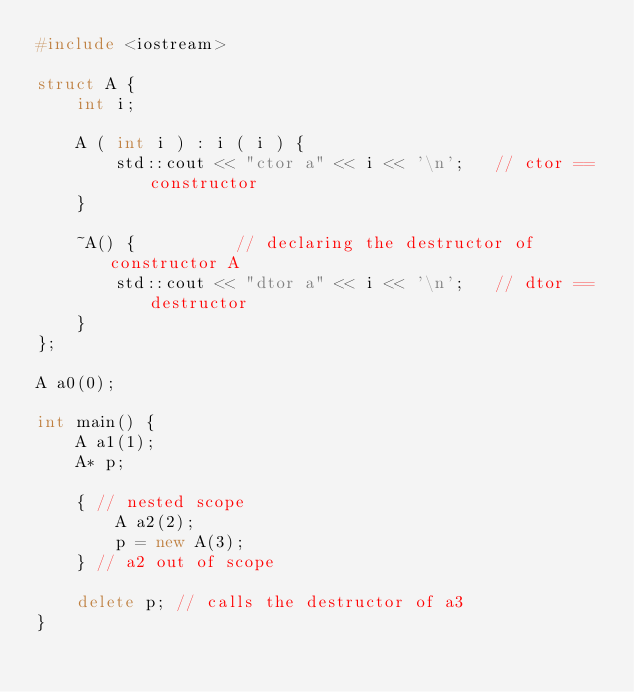Convert code to text. <code><loc_0><loc_0><loc_500><loc_500><_C++_>#include <iostream>
 
struct A {
    int i;
 
    A ( int i ) : i ( i ) {
        std::cout << "ctor a" << i << '\n';   // ctor == constructor
    }

    ~A() {          // declaring the destructor of constructor A
        std::cout << "dtor a" << i << '\n';   // dtor == destructor
    }
};
 
A a0(0);
 
int main() {
    A a1(1);
    A* p;
 
    { // nested scope
        A a2(2);
        p = new A(3);
    } // a2 out of scope
 
    delete p; // calls the destructor of a3
}</code> 